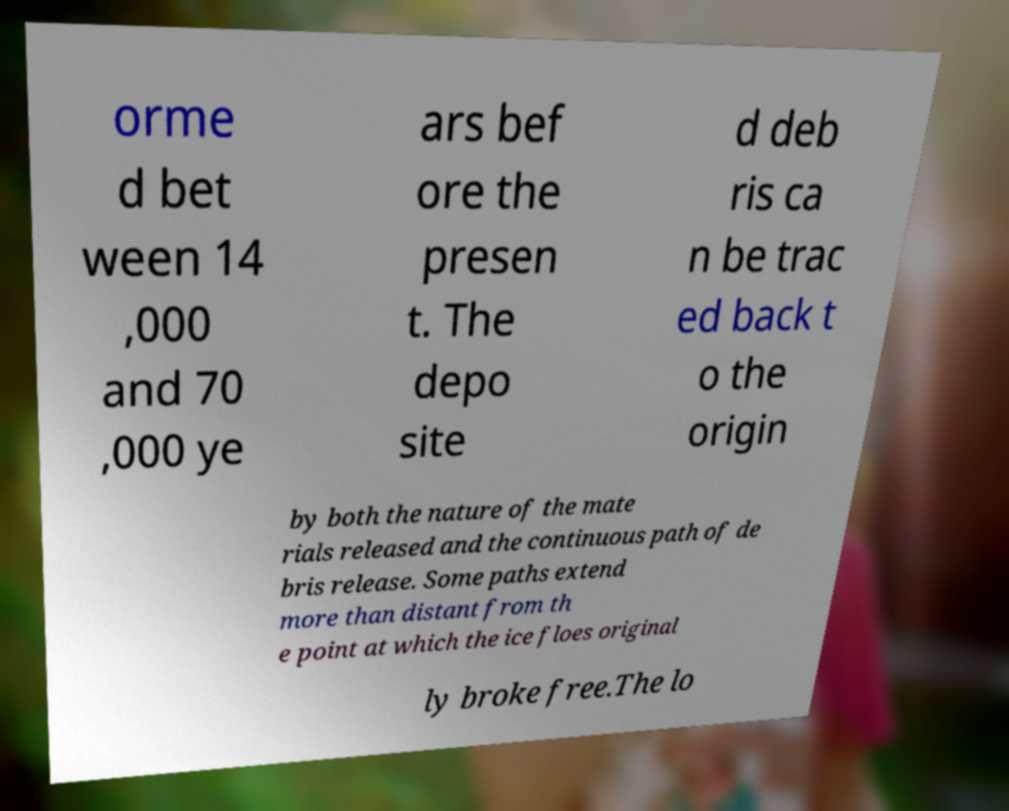I need the written content from this picture converted into text. Can you do that? orme d bet ween 14 ,000 and 70 ,000 ye ars bef ore the presen t. The depo site d deb ris ca n be trac ed back t o the origin by both the nature of the mate rials released and the continuous path of de bris release. Some paths extend more than distant from th e point at which the ice floes original ly broke free.The lo 